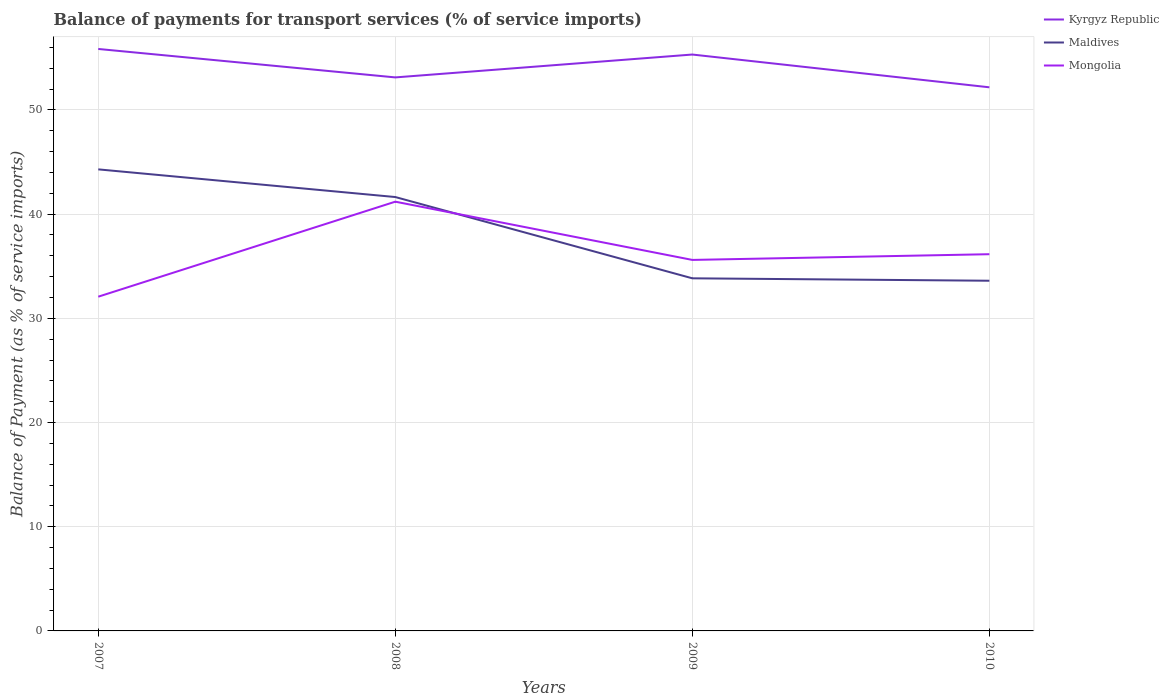How many different coloured lines are there?
Make the answer very short. 3. Is the number of lines equal to the number of legend labels?
Keep it short and to the point. Yes. Across all years, what is the maximum balance of payments for transport services in Kyrgyz Republic?
Provide a succinct answer. 52.17. In which year was the balance of payments for transport services in Mongolia maximum?
Offer a very short reply. 2007. What is the total balance of payments for transport services in Mongolia in the graph?
Keep it short and to the point. -9.12. What is the difference between the highest and the second highest balance of payments for transport services in Kyrgyz Republic?
Keep it short and to the point. 3.68. Is the balance of payments for transport services in Mongolia strictly greater than the balance of payments for transport services in Maldives over the years?
Your answer should be compact. No. How many lines are there?
Give a very brief answer. 3. Does the graph contain any zero values?
Make the answer very short. No. Where does the legend appear in the graph?
Make the answer very short. Top right. How many legend labels are there?
Offer a very short reply. 3. How are the legend labels stacked?
Offer a terse response. Vertical. What is the title of the graph?
Make the answer very short. Balance of payments for transport services (% of service imports). What is the label or title of the Y-axis?
Offer a terse response. Balance of Payment (as % of service imports). What is the Balance of Payment (as % of service imports) in Kyrgyz Republic in 2007?
Give a very brief answer. 55.85. What is the Balance of Payment (as % of service imports) in Maldives in 2007?
Make the answer very short. 44.29. What is the Balance of Payment (as % of service imports) of Mongolia in 2007?
Provide a succinct answer. 32.08. What is the Balance of Payment (as % of service imports) of Kyrgyz Republic in 2008?
Offer a terse response. 53.12. What is the Balance of Payment (as % of service imports) in Maldives in 2008?
Give a very brief answer. 41.64. What is the Balance of Payment (as % of service imports) of Mongolia in 2008?
Make the answer very short. 41.19. What is the Balance of Payment (as % of service imports) in Kyrgyz Republic in 2009?
Offer a very short reply. 55.32. What is the Balance of Payment (as % of service imports) in Maldives in 2009?
Your answer should be compact. 33.84. What is the Balance of Payment (as % of service imports) in Mongolia in 2009?
Your answer should be compact. 35.6. What is the Balance of Payment (as % of service imports) of Kyrgyz Republic in 2010?
Provide a succinct answer. 52.17. What is the Balance of Payment (as % of service imports) in Maldives in 2010?
Your response must be concise. 33.61. What is the Balance of Payment (as % of service imports) of Mongolia in 2010?
Your answer should be very brief. 36.15. Across all years, what is the maximum Balance of Payment (as % of service imports) of Kyrgyz Republic?
Make the answer very short. 55.85. Across all years, what is the maximum Balance of Payment (as % of service imports) of Maldives?
Provide a succinct answer. 44.29. Across all years, what is the maximum Balance of Payment (as % of service imports) of Mongolia?
Provide a short and direct response. 41.19. Across all years, what is the minimum Balance of Payment (as % of service imports) in Kyrgyz Republic?
Your answer should be very brief. 52.17. Across all years, what is the minimum Balance of Payment (as % of service imports) in Maldives?
Keep it short and to the point. 33.61. Across all years, what is the minimum Balance of Payment (as % of service imports) of Mongolia?
Provide a short and direct response. 32.08. What is the total Balance of Payment (as % of service imports) of Kyrgyz Republic in the graph?
Offer a very short reply. 216.46. What is the total Balance of Payment (as % of service imports) of Maldives in the graph?
Your answer should be very brief. 153.38. What is the total Balance of Payment (as % of service imports) in Mongolia in the graph?
Make the answer very short. 145.03. What is the difference between the Balance of Payment (as % of service imports) in Kyrgyz Republic in 2007 and that in 2008?
Give a very brief answer. 2.73. What is the difference between the Balance of Payment (as % of service imports) in Maldives in 2007 and that in 2008?
Your response must be concise. 2.66. What is the difference between the Balance of Payment (as % of service imports) of Mongolia in 2007 and that in 2008?
Your answer should be very brief. -9.12. What is the difference between the Balance of Payment (as % of service imports) of Kyrgyz Republic in 2007 and that in 2009?
Make the answer very short. 0.53. What is the difference between the Balance of Payment (as % of service imports) of Maldives in 2007 and that in 2009?
Your answer should be compact. 10.45. What is the difference between the Balance of Payment (as % of service imports) in Mongolia in 2007 and that in 2009?
Ensure brevity in your answer.  -3.53. What is the difference between the Balance of Payment (as % of service imports) of Kyrgyz Republic in 2007 and that in 2010?
Provide a succinct answer. 3.68. What is the difference between the Balance of Payment (as % of service imports) of Maldives in 2007 and that in 2010?
Your answer should be very brief. 10.69. What is the difference between the Balance of Payment (as % of service imports) in Mongolia in 2007 and that in 2010?
Offer a terse response. -4.08. What is the difference between the Balance of Payment (as % of service imports) of Kyrgyz Republic in 2008 and that in 2009?
Your response must be concise. -2.19. What is the difference between the Balance of Payment (as % of service imports) in Maldives in 2008 and that in 2009?
Offer a terse response. 7.8. What is the difference between the Balance of Payment (as % of service imports) in Mongolia in 2008 and that in 2009?
Offer a very short reply. 5.59. What is the difference between the Balance of Payment (as % of service imports) of Kyrgyz Republic in 2008 and that in 2010?
Provide a succinct answer. 0.95. What is the difference between the Balance of Payment (as % of service imports) in Maldives in 2008 and that in 2010?
Ensure brevity in your answer.  8.03. What is the difference between the Balance of Payment (as % of service imports) of Mongolia in 2008 and that in 2010?
Offer a terse response. 5.04. What is the difference between the Balance of Payment (as % of service imports) in Kyrgyz Republic in 2009 and that in 2010?
Your answer should be compact. 3.15. What is the difference between the Balance of Payment (as % of service imports) in Maldives in 2009 and that in 2010?
Offer a terse response. 0.23. What is the difference between the Balance of Payment (as % of service imports) in Mongolia in 2009 and that in 2010?
Provide a succinct answer. -0.55. What is the difference between the Balance of Payment (as % of service imports) in Kyrgyz Republic in 2007 and the Balance of Payment (as % of service imports) in Maldives in 2008?
Ensure brevity in your answer.  14.21. What is the difference between the Balance of Payment (as % of service imports) in Kyrgyz Republic in 2007 and the Balance of Payment (as % of service imports) in Mongolia in 2008?
Offer a very short reply. 14.66. What is the difference between the Balance of Payment (as % of service imports) of Maldives in 2007 and the Balance of Payment (as % of service imports) of Mongolia in 2008?
Give a very brief answer. 3.1. What is the difference between the Balance of Payment (as % of service imports) in Kyrgyz Republic in 2007 and the Balance of Payment (as % of service imports) in Maldives in 2009?
Provide a succinct answer. 22.01. What is the difference between the Balance of Payment (as % of service imports) of Kyrgyz Republic in 2007 and the Balance of Payment (as % of service imports) of Mongolia in 2009?
Provide a short and direct response. 20.25. What is the difference between the Balance of Payment (as % of service imports) of Maldives in 2007 and the Balance of Payment (as % of service imports) of Mongolia in 2009?
Ensure brevity in your answer.  8.69. What is the difference between the Balance of Payment (as % of service imports) in Kyrgyz Republic in 2007 and the Balance of Payment (as % of service imports) in Maldives in 2010?
Provide a succinct answer. 22.24. What is the difference between the Balance of Payment (as % of service imports) in Kyrgyz Republic in 2007 and the Balance of Payment (as % of service imports) in Mongolia in 2010?
Offer a very short reply. 19.7. What is the difference between the Balance of Payment (as % of service imports) of Maldives in 2007 and the Balance of Payment (as % of service imports) of Mongolia in 2010?
Your answer should be very brief. 8.14. What is the difference between the Balance of Payment (as % of service imports) in Kyrgyz Republic in 2008 and the Balance of Payment (as % of service imports) in Maldives in 2009?
Make the answer very short. 19.28. What is the difference between the Balance of Payment (as % of service imports) in Kyrgyz Republic in 2008 and the Balance of Payment (as % of service imports) in Mongolia in 2009?
Give a very brief answer. 17.52. What is the difference between the Balance of Payment (as % of service imports) of Maldives in 2008 and the Balance of Payment (as % of service imports) of Mongolia in 2009?
Provide a succinct answer. 6.03. What is the difference between the Balance of Payment (as % of service imports) in Kyrgyz Republic in 2008 and the Balance of Payment (as % of service imports) in Maldives in 2010?
Provide a short and direct response. 19.51. What is the difference between the Balance of Payment (as % of service imports) in Kyrgyz Republic in 2008 and the Balance of Payment (as % of service imports) in Mongolia in 2010?
Your answer should be compact. 16.97. What is the difference between the Balance of Payment (as % of service imports) of Maldives in 2008 and the Balance of Payment (as % of service imports) of Mongolia in 2010?
Provide a succinct answer. 5.49. What is the difference between the Balance of Payment (as % of service imports) of Kyrgyz Republic in 2009 and the Balance of Payment (as % of service imports) of Maldives in 2010?
Offer a terse response. 21.71. What is the difference between the Balance of Payment (as % of service imports) of Kyrgyz Republic in 2009 and the Balance of Payment (as % of service imports) of Mongolia in 2010?
Your answer should be very brief. 19.16. What is the difference between the Balance of Payment (as % of service imports) of Maldives in 2009 and the Balance of Payment (as % of service imports) of Mongolia in 2010?
Make the answer very short. -2.31. What is the average Balance of Payment (as % of service imports) of Kyrgyz Republic per year?
Ensure brevity in your answer.  54.11. What is the average Balance of Payment (as % of service imports) of Maldives per year?
Offer a terse response. 38.35. What is the average Balance of Payment (as % of service imports) of Mongolia per year?
Your answer should be very brief. 36.26. In the year 2007, what is the difference between the Balance of Payment (as % of service imports) in Kyrgyz Republic and Balance of Payment (as % of service imports) in Maldives?
Give a very brief answer. 11.56. In the year 2007, what is the difference between the Balance of Payment (as % of service imports) in Kyrgyz Republic and Balance of Payment (as % of service imports) in Mongolia?
Keep it short and to the point. 23.77. In the year 2007, what is the difference between the Balance of Payment (as % of service imports) in Maldives and Balance of Payment (as % of service imports) in Mongolia?
Provide a succinct answer. 12.22. In the year 2008, what is the difference between the Balance of Payment (as % of service imports) of Kyrgyz Republic and Balance of Payment (as % of service imports) of Maldives?
Provide a succinct answer. 11.48. In the year 2008, what is the difference between the Balance of Payment (as % of service imports) of Kyrgyz Republic and Balance of Payment (as % of service imports) of Mongolia?
Offer a terse response. 11.93. In the year 2008, what is the difference between the Balance of Payment (as % of service imports) of Maldives and Balance of Payment (as % of service imports) of Mongolia?
Ensure brevity in your answer.  0.44. In the year 2009, what is the difference between the Balance of Payment (as % of service imports) of Kyrgyz Republic and Balance of Payment (as % of service imports) of Maldives?
Offer a terse response. 21.48. In the year 2009, what is the difference between the Balance of Payment (as % of service imports) in Kyrgyz Republic and Balance of Payment (as % of service imports) in Mongolia?
Your response must be concise. 19.71. In the year 2009, what is the difference between the Balance of Payment (as % of service imports) in Maldives and Balance of Payment (as % of service imports) in Mongolia?
Offer a terse response. -1.76. In the year 2010, what is the difference between the Balance of Payment (as % of service imports) of Kyrgyz Republic and Balance of Payment (as % of service imports) of Maldives?
Provide a succinct answer. 18.56. In the year 2010, what is the difference between the Balance of Payment (as % of service imports) of Kyrgyz Republic and Balance of Payment (as % of service imports) of Mongolia?
Make the answer very short. 16.02. In the year 2010, what is the difference between the Balance of Payment (as % of service imports) in Maldives and Balance of Payment (as % of service imports) in Mongolia?
Provide a short and direct response. -2.55. What is the ratio of the Balance of Payment (as % of service imports) of Kyrgyz Republic in 2007 to that in 2008?
Provide a short and direct response. 1.05. What is the ratio of the Balance of Payment (as % of service imports) of Maldives in 2007 to that in 2008?
Your answer should be very brief. 1.06. What is the ratio of the Balance of Payment (as % of service imports) of Mongolia in 2007 to that in 2008?
Provide a succinct answer. 0.78. What is the ratio of the Balance of Payment (as % of service imports) of Kyrgyz Republic in 2007 to that in 2009?
Ensure brevity in your answer.  1.01. What is the ratio of the Balance of Payment (as % of service imports) in Maldives in 2007 to that in 2009?
Your answer should be very brief. 1.31. What is the ratio of the Balance of Payment (as % of service imports) in Mongolia in 2007 to that in 2009?
Offer a very short reply. 0.9. What is the ratio of the Balance of Payment (as % of service imports) in Kyrgyz Republic in 2007 to that in 2010?
Your answer should be compact. 1.07. What is the ratio of the Balance of Payment (as % of service imports) of Maldives in 2007 to that in 2010?
Give a very brief answer. 1.32. What is the ratio of the Balance of Payment (as % of service imports) in Mongolia in 2007 to that in 2010?
Provide a succinct answer. 0.89. What is the ratio of the Balance of Payment (as % of service imports) of Kyrgyz Republic in 2008 to that in 2009?
Offer a very short reply. 0.96. What is the ratio of the Balance of Payment (as % of service imports) in Maldives in 2008 to that in 2009?
Provide a succinct answer. 1.23. What is the ratio of the Balance of Payment (as % of service imports) of Mongolia in 2008 to that in 2009?
Give a very brief answer. 1.16. What is the ratio of the Balance of Payment (as % of service imports) of Kyrgyz Republic in 2008 to that in 2010?
Ensure brevity in your answer.  1.02. What is the ratio of the Balance of Payment (as % of service imports) in Maldives in 2008 to that in 2010?
Keep it short and to the point. 1.24. What is the ratio of the Balance of Payment (as % of service imports) in Mongolia in 2008 to that in 2010?
Ensure brevity in your answer.  1.14. What is the ratio of the Balance of Payment (as % of service imports) of Kyrgyz Republic in 2009 to that in 2010?
Offer a very short reply. 1.06. What is the ratio of the Balance of Payment (as % of service imports) in Maldives in 2009 to that in 2010?
Provide a succinct answer. 1.01. What is the difference between the highest and the second highest Balance of Payment (as % of service imports) of Kyrgyz Republic?
Make the answer very short. 0.53. What is the difference between the highest and the second highest Balance of Payment (as % of service imports) of Maldives?
Your response must be concise. 2.66. What is the difference between the highest and the second highest Balance of Payment (as % of service imports) of Mongolia?
Your answer should be very brief. 5.04. What is the difference between the highest and the lowest Balance of Payment (as % of service imports) of Kyrgyz Republic?
Offer a very short reply. 3.68. What is the difference between the highest and the lowest Balance of Payment (as % of service imports) in Maldives?
Provide a succinct answer. 10.69. What is the difference between the highest and the lowest Balance of Payment (as % of service imports) of Mongolia?
Your answer should be very brief. 9.12. 